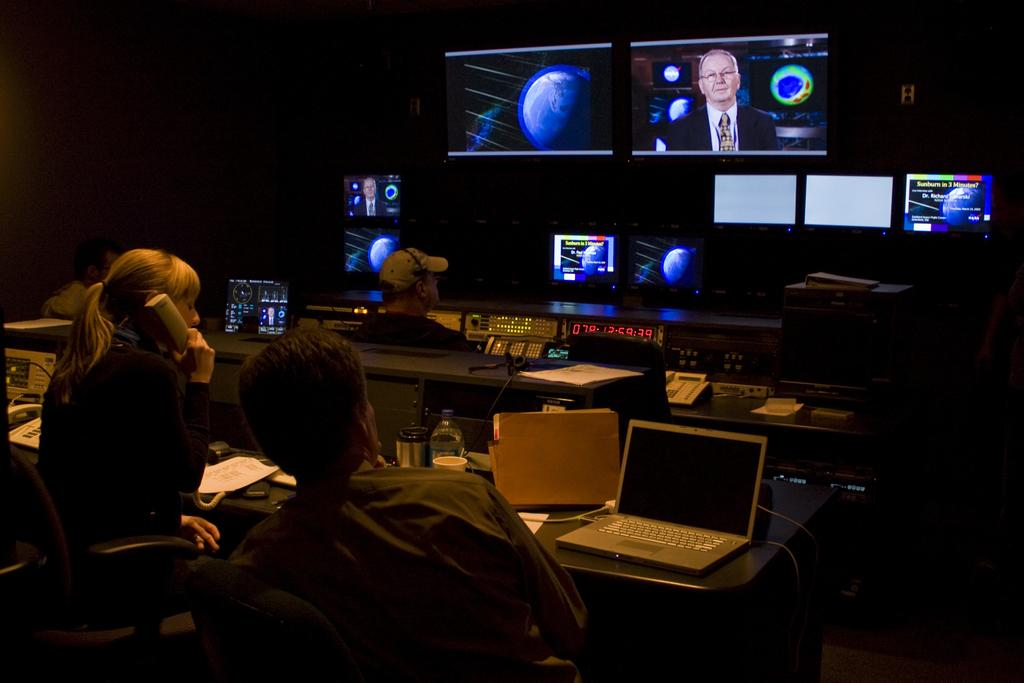<image>
Render a clear and concise summary of the photo. Two people in front of screens with a large clock reading 078:12:59:39. 